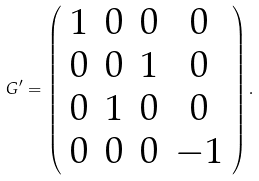<formula> <loc_0><loc_0><loc_500><loc_500>G ^ { \prime } = \left ( \begin{array} { c c c c } 1 & 0 & 0 & 0 \\ 0 & 0 & 1 & 0 \\ 0 & 1 & 0 & 0 \\ 0 & 0 & 0 & - 1 \end{array} \right ) .</formula> 